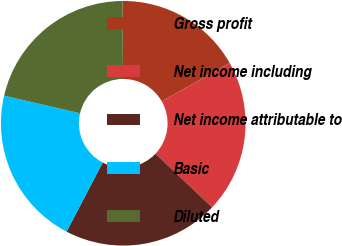Convert chart. <chart><loc_0><loc_0><loc_500><loc_500><pie_chart><fcel>Gross profit<fcel>Net income including<fcel>Net income attributable to<fcel>Basic<fcel>Diluted<nl><fcel>16.89%<fcel>20.27%<fcel>20.61%<fcel>20.95%<fcel>21.28%<nl></chart> 